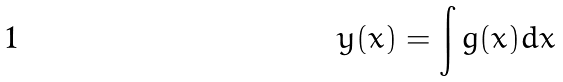<formula> <loc_0><loc_0><loc_500><loc_500>y ( x ) = \int g ( x ) d x</formula> 